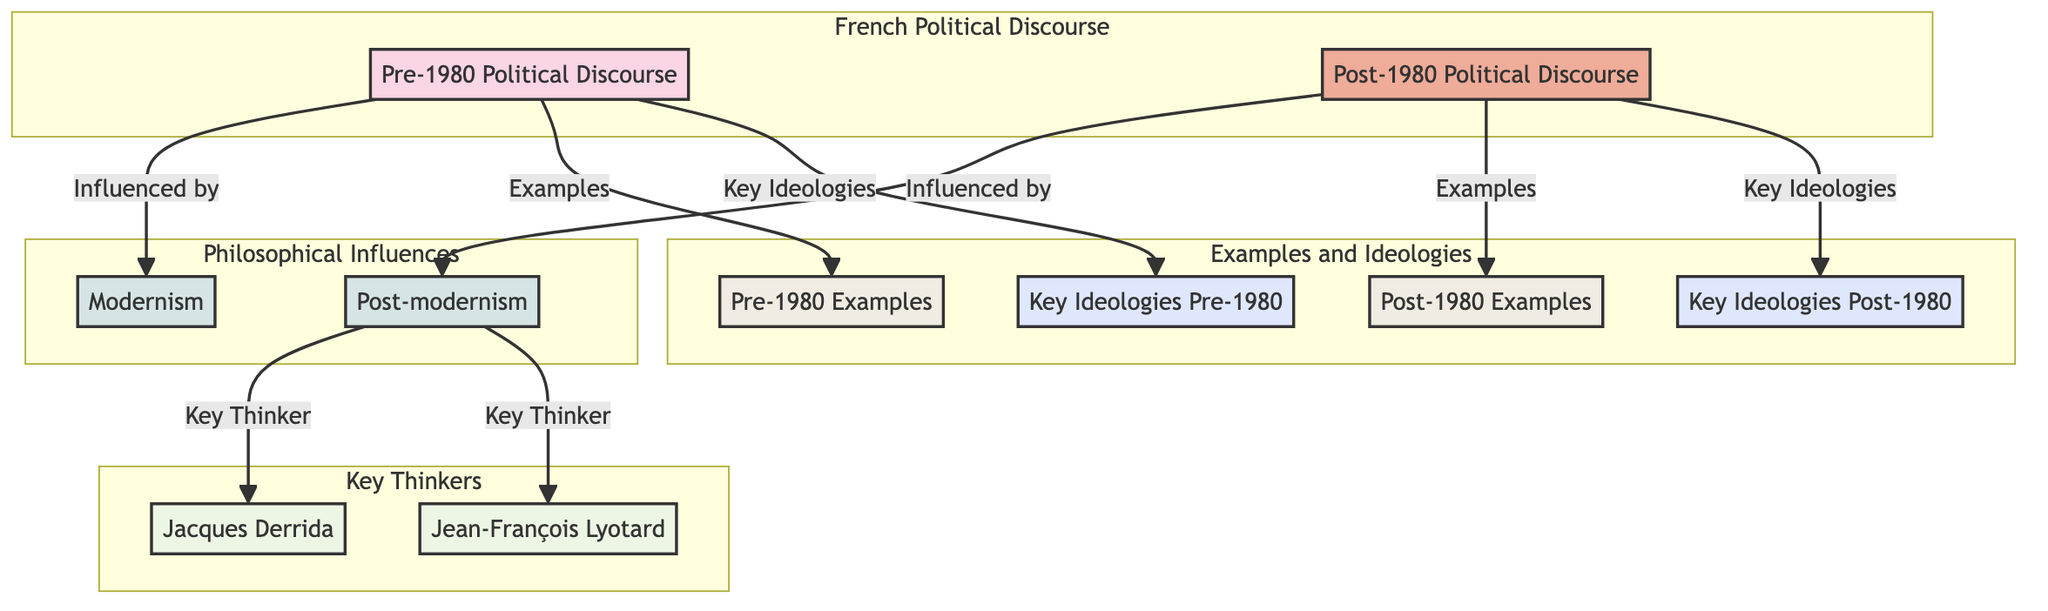What influenced Pre-1980 Political Discourse? The diagram indicates that Modernism influenced Pre-1980 Political Discourse. By following the arrow from the Pre-1980 node, we can see the direct relationship that connects it to Modernism.
Answer: Modernism Who are the key thinkers of post-modernism? The diagram specifies that Jacques Derrida and Jean-François Lyotard are the key thinkers associated with post-modernism. Looking at the flow from post-modernism, we identify both individuals as prominent figures.
Answer: Jacques Derrida, Jean-François Lyotard How many examples are provided for post-1980 political discourse? According to the diagram, the Post-1980 Political Discourse node leads to a single Examples node, indicating there is one collective set of examples for this category.
Answer: 1 What are the key ideologies in Pre-1980 Political Discourse? The diagram connects the Pre-1980 Political Discourse to a Key Ideologies node. This suggests that several key ideologies are aggregated under this connection, pointing towards a group rather than specifics.
Answer: Key Ideologies What philosophical influence characterizes post-1980 political discourse? The diagram shows an arrow from Post-1980 Political Discourse to Post-modernism, indicating that post-modernism is the philosophical influence for this era of discourse.
Answer: Post-modernism Is there a direct relationship between Pre-1980 and Post-1980 political discourses? Analyzing the diagram reveals that there is no direct connection or edge between the Pre-1980 and Post-1980 nodes, which indicates they are separate entities without a direct relationship indicated.
Answer: No What does the subgraph "Philosophical Influences" contain? The subgraph for Philosophical Influences explicitly shows two nodes: Modernism and Post-modernism. This means both philosophies are categorized under this subgraph without any other elements included.
Answer: Modernism, Post-modernism What type of examples are associated with post-1980 political discourse? The diagram clearly links Post-1980 Political Discourse to a designated Examples node, implying that specific instances exist that illustrate this discourse, but without enumerating these examples.
Answer: Examples 